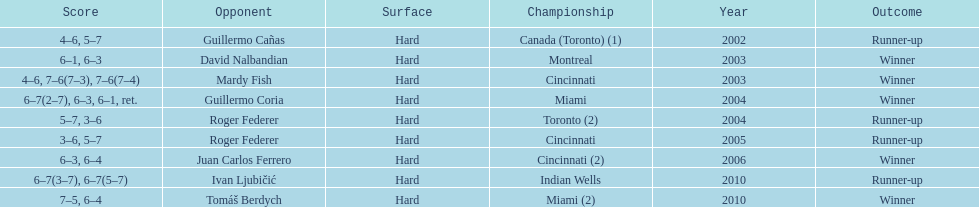In toronto or montreal, how many championship events have been held? 3. 